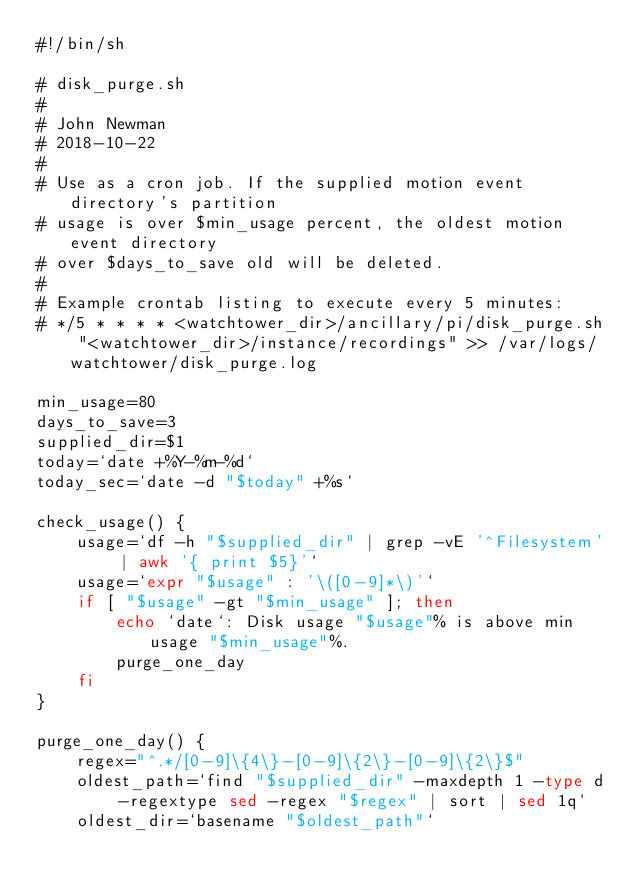<code> <loc_0><loc_0><loc_500><loc_500><_Bash_>#!/bin/sh

# disk_purge.sh
#
# John Newman
# 2018-10-22
#
# Use as a cron job. If the supplied motion event directory's partition
# usage is over $min_usage percent, the oldest motion event directory
# over $days_to_save old will be deleted.
#
# Example crontab listing to execute every 5 minutes:
# */5 * * * * <watchtower_dir>/ancillary/pi/disk_purge.sh "<watchtower_dir>/instance/recordings" >> /var/logs/watchtower/disk_purge.log

min_usage=80
days_to_save=3
supplied_dir=$1
today=`date +%Y-%m-%d`
today_sec=`date -d "$today" +%s`

check_usage() {
    usage=`df -h "$supplied_dir" | grep -vE '^Filesystem' | awk '{ print $5}'`
    usage=`expr "$usage" : '\([0-9]*\)'`
    if [ "$usage" -gt "$min_usage" ]; then
        echo `date`: Disk usage "$usage"% is above min usage "$min_usage"%.
        purge_one_day
    fi
}

purge_one_day() {
    regex="^.*/[0-9]\{4\}-[0-9]\{2\}-[0-9]\{2\}$"
    oldest_path=`find "$supplied_dir" -maxdepth 1 -type d -regextype sed -regex "$regex" | sort | sed 1q`
    oldest_dir=`basename "$oldest_path"`</code> 